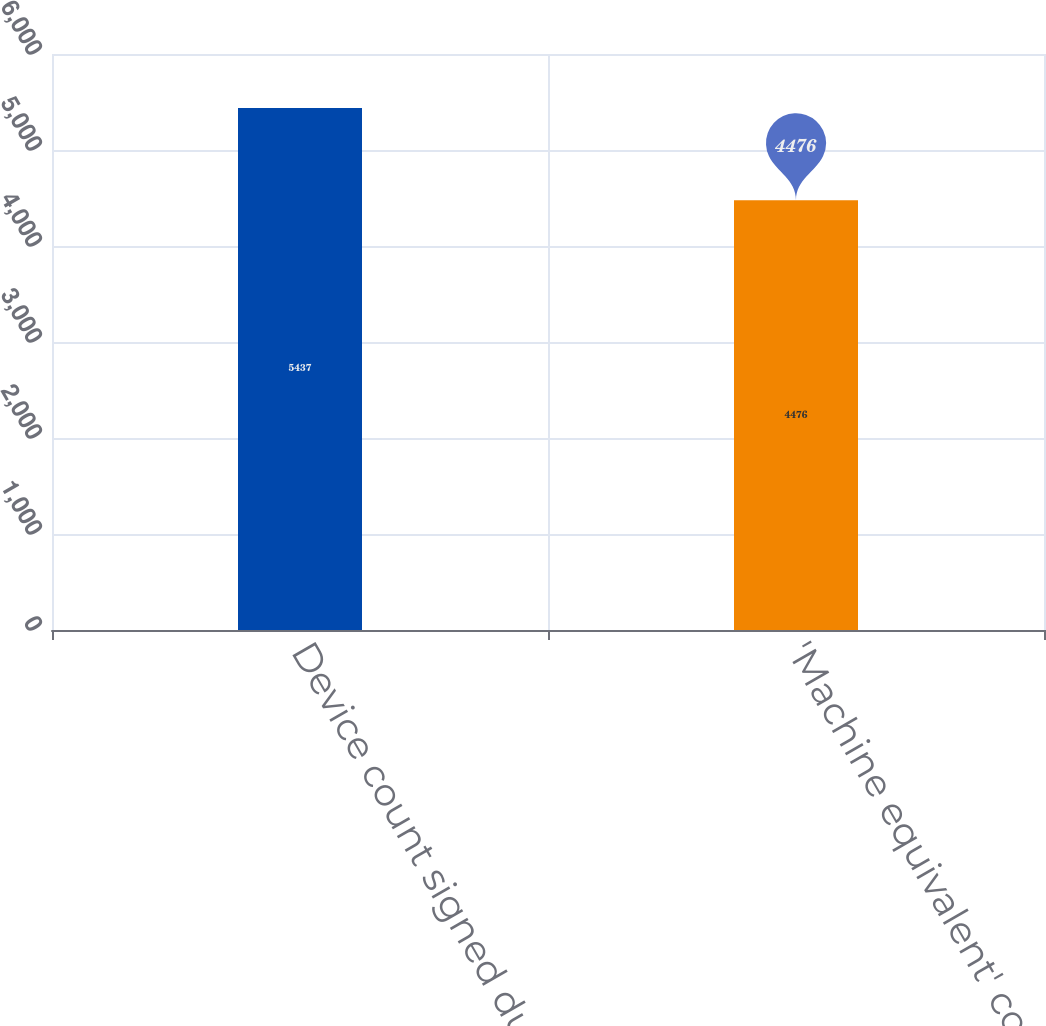Convert chart. <chart><loc_0><loc_0><loc_500><loc_500><bar_chart><fcel>Device count signed during the<fcel>'Machine equivalent' count<nl><fcel>5437<fcel>4476<nl></chart> 